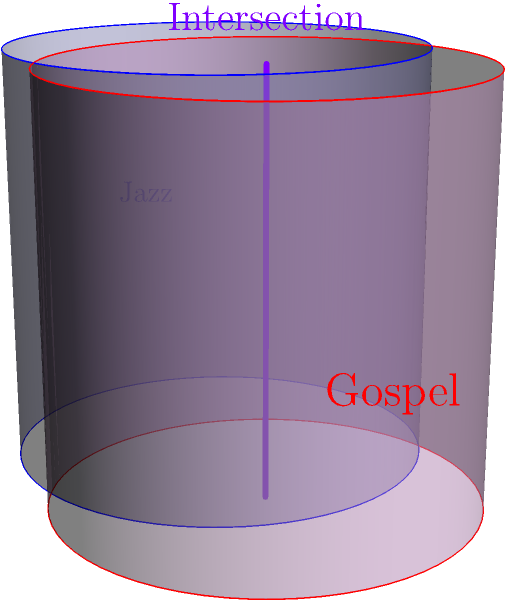In the diagram, two cylindrical objects represent the influences of jazz and gospel music. The blue cylinder symbolizes jazz, while the red cylinder represents gospel. If both cylinders have a radius of 1 unit and a height of 2 units, with their centers offset by $(\frac{1}{2}, \frac{1}{2}, 0)$, what is the length of the line segment representing their intersection? To find the length of the intersection line segment, we need to follow these steps:

1) The intersection of two cylinders with the same radius and height, offset horizontally, will be a straight line segment.

2) The line segment will start at the bottom of the cylinders (z = 0) and end at the top (z = 2), as both cylinders have the same height.

3) The length of this line segment will be equal to the height of the cylinders.

4) In this case, the height of both cylinders is given as 2 units.

Therefore, the length of the line segment representing the intersection of the jazz and gospel influence cylinders is 2 units.

This intersection symbolizes the fusion point of jazz and gospel influences, representing how these two musical styles can blend and create a unique sound, which is particularly relevant for a jazz pianist interpreting gospel music.
Answer: 2 units 